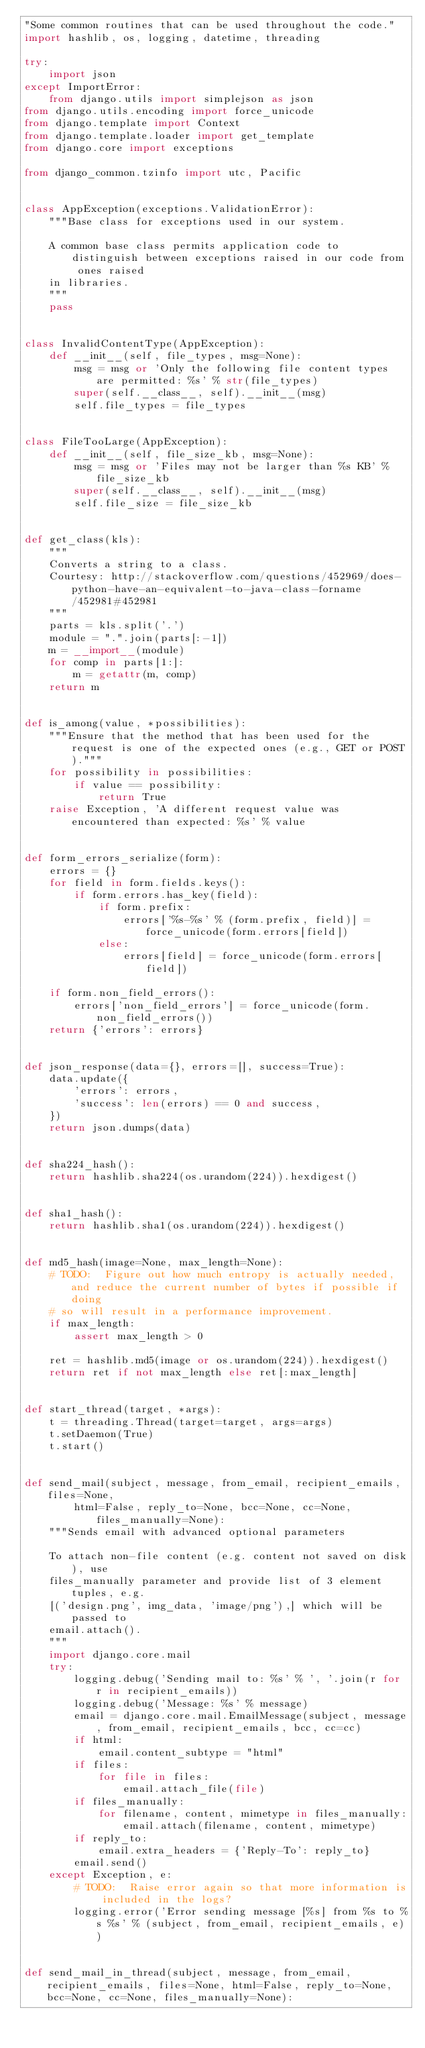Convert code to text. <code><loc_0><loc_0><loc_500><loc_500><_Python_>"Some common routines that can be used throughout the code."
import hashlib, os, logging, datetime, threading

try:
    import json
except ImportError:
    from django.utils import simplejson as json
from django.utils.encoding import force_unicode
from django.template import Context
from django.template.loader import get_template
from django.core import exceptions

from django_common.tzinfo import utc, Pacific


class AppException(exceptions.ValidationError):
    """Base class for exceptions used in our system.

    A common base class permits application code to distinguish between exceptions raised in our code from ones raised
    in libraries.
    """
    pass


class InvalidContentType(AppException):
    def __init__(self, file_types, msg=None):
        msg = msg or 'Only the following file content types are permitted: %s' % str(file_types)
        super(self.__class__, self).__init__(msg)
        self.file_types = file_types


class FileTooLarge(AppException):
    def __init__(self, file_size_kb, msg=None):
        msg = msg or 'Files may not be larger than %s KB' % file_size_kb
        super(self.__class__, self).__init__(msg)
        self.file_size = file_size_kb


def get_class(kls):
    """
    Converts a string to a class.
    Courtesy: http://stackoverflow.com/questions/452969/does-python-have-an-equivalent-to-java-class-forname/452981#452981
    """
    parts = kls.split('.')
    module = ".".join(parts[:-1])
    m = __import__(module)
    for comp in parts[1:]:
        m = getattr(m, comp)
    return m


def is_among(value, *possibilities):
    """Ensure that the method that has been used for the request is one of the expected ones (e.g., GET or POST)."""
    for possibility in possibilities:
        if value == possibility:
            return True
    raise Exception, 'A different request value was encountered than expected: %s' % value


def form_errors_serialize(form):
    errors = {}
    for field in form.fields.keys():
        if form.errors.has_key(field):
            if form.prefix:
                errors['%s-%s' % (form.prefix, field)] = force_unicode(form.errors[field])
            else:
                errors[field] = force_unicode(form.errors[field])

    if form.non_field_errors():
        errors['non_field_errors'] = force_unicode(form.non_field_errors())
    return {'errors': errors}


def json_response(data={}, errors=[], success=True):
    data.update({
        'errors': errors,
        'success': len(errors) == 0 and success,
    })
    return json.dumps(data)


def sha224_hash():
    return hashlib.sha224(os.urandom(224)).hexdigest()


def sha1_hash():
    return hashlib.sha1(os.urandom(224)).hexdigest()


def md5_hash(image=None, max_length=None):
    # TODO:  Figure out how much entropy is actually needed, and reduce the current number of bytes if possible if doing
    # so will result in a performance improvement.
    if max_length:
        assert max_length > 0

    ret = hashlib.md5(image or os.urandom(224)).hexdigest()
    return ret if not max_length else ret[:max_length]


def start_thread(target, *args):
    t = threading.Thread(target=target, args=args)
    t.setDaemon(True)
    t.start()


def send_mail(subject, message, from_email, recipient_emails, files=None,
        html=False, reply_to=None, bcc=None, cc=None, files_manually=None):
    """Sends email with advanced optional parameters

    To attach non-file content (e.g. content not saved on disk), use
    files_manually parameter and provide list of 3 element tuples, e.g.
    [('design.png', img_data, 'image/png'),] which will be passed to
    email.attach().
    """
    import django.core.mail
    try:
        logging.debug('Sending mail to: %s' % ', '.join(r for r in recipient_emails))
        logging.debug('Message: %s' % message)
        email = django.core.mail.EmailMessage(subject, message, from_email, recipient_emails, bcc, cc=cc)
        if html:
            email.content_subtype = "html"
        if files:
            for file in files:
                email.attach_file(file)
        if files_manually:
            for filename, content, mimetype in files_manually:
                email.attach(filename, content, mimetype)
        if reply_to:
            email.extra_headers = {'Reply-To': reply_to}
        email.send()
    except Exception, e:
        # TODO:  Raise error again so that more information is included in the logs?
        logging.error('Error sending message [%s] from %s to %s %s' % (subject, from_email, recipient_emails, e))


def send_mail_in_thread(subject, message, from_email, recipient_emails, files=None, html=False, reply_to=None, bcc=None, cc=None, files_manually=None):</code> 